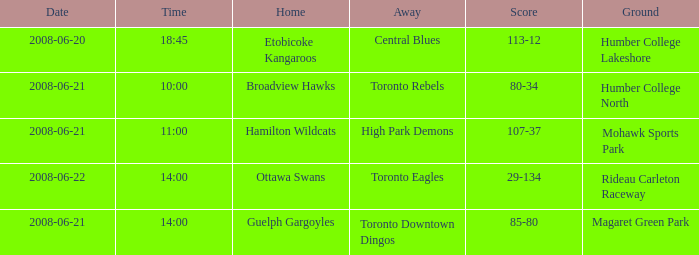What is the surface with a date that is 2008-06-20? Humber College Lakeshore. 